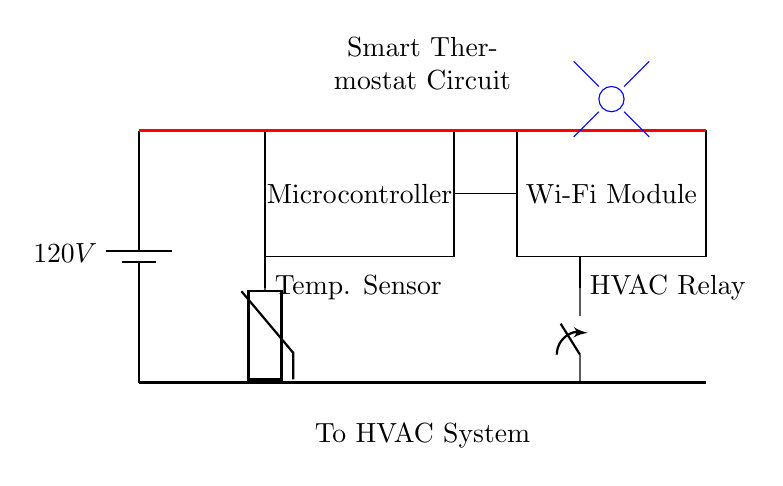What is the main power supply voltage for this circuit? The circuit diagram indicates that the main power supply is represented by a battery labeled with 120V. This is directly labeled on the component in the diagram.
Answer: 120V What component is responsible for Wi-Fi connectivity? The diagram features a rectangle labeled "Wi-Fi Module." This denotes the specific component designed to provide Wi-Fi connectivity for remote operations.
Answer: Wi-Fi Module How many main components are in this circuit? By counting the distinct labeled components in the diagram, we find a microcontroller, a Wi-Fi module, a temperature sensor, and an HVAC relay, totaling four main components.
Answer: Four What type of sensor is used in this circuit? The diagram features a component labeled "Temp. Sensor," which indicates that it is a temperature sensor, specifically used for measuring temperature.
Answer: Temperature sensor How does the microcontroller connect to the temperature sensor? The connection is shown in the diagram with a line drawn from the temperature sensor to the microcontroller, indicating that the microcontroller receives data from the temperature sensor for processing.
Answer: Direct line connection What is the purpose of the HVAC relay in the circuit? The HVAC relay is shown in the diagram, and its role is to control the heating, ventilation, and air conditioning system based on the commands from the microcontroller, allowing for effective temperature management in the home.
Answer: Control HVAC system What does the blue symbol with lines represent in the circuit? The blue circle with lines extending from it represents a Wi-Fi signal symbol, visually indicating the wireless connectivity feature provided by the Wi-Fi module in the circuit.
Answer: Wi-Fi signal 